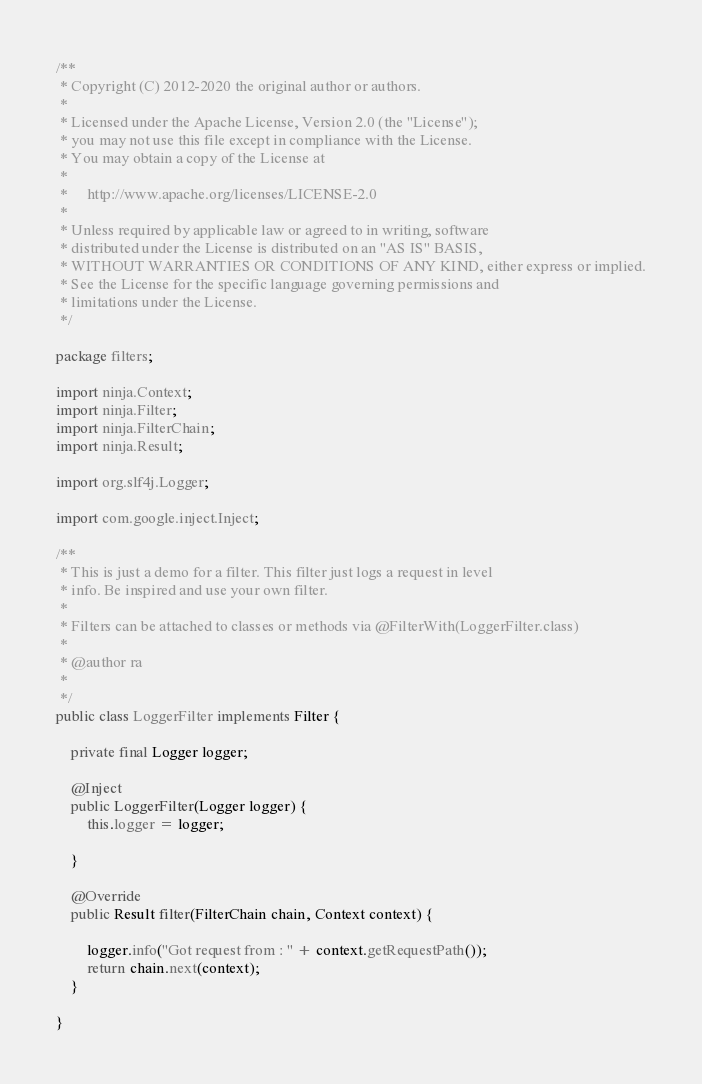<code> <loc_0><loc_0><loc_500><loc_500><_Java_>/**
 * Copyright (C) 2012-2020 the original author or authors.
 *
 * Licensed under the Apache License, Version 2.0 (the "License");
 * you may not use this file except in compliance with the License.
 * You may obtain a copy of the License at
 *
 *     http://www.apache.org/licenses/LICENSE-2.0
 *
 * Unless required by applicable law or agreed to in writing, software
 * distributed under the License is distributed on an "AS IS" BASIS,
 * WITHOUT WARRANTIES OR CONDITIONS OF ANY KIND, either express or implied.
 * See the License for the specific language governing permissions and
 * limitations under the License.
 */

package filters;

import ninja.Context;
import ninja.Filter;
import ninja.FilterChain;
import ninja.Result;

import org.slf4j.Logger;

import com.google.inject.Inject;

/**
 * This is just a demo for a filter. This filter just logs a request in level
 * info. Be inspired and use your own filter.
 * 
 * Filters can be attached to classes or methods via @FilterWith(LoggerFilter.class)
 * 
 * @author ra
 * 
 */
public class LoggerFilter implements Filter {

    private final Logger logger;

    @Inject
    public LoggerFilter(Logger logger) {
        this.logger = logger;

    }

    @Override
    public Result filter(FilterChain chain, Context context) {

        logger.info("Got request from : " + context.getRequestPath());
        return chain.next(context);
    }

}
</code> 